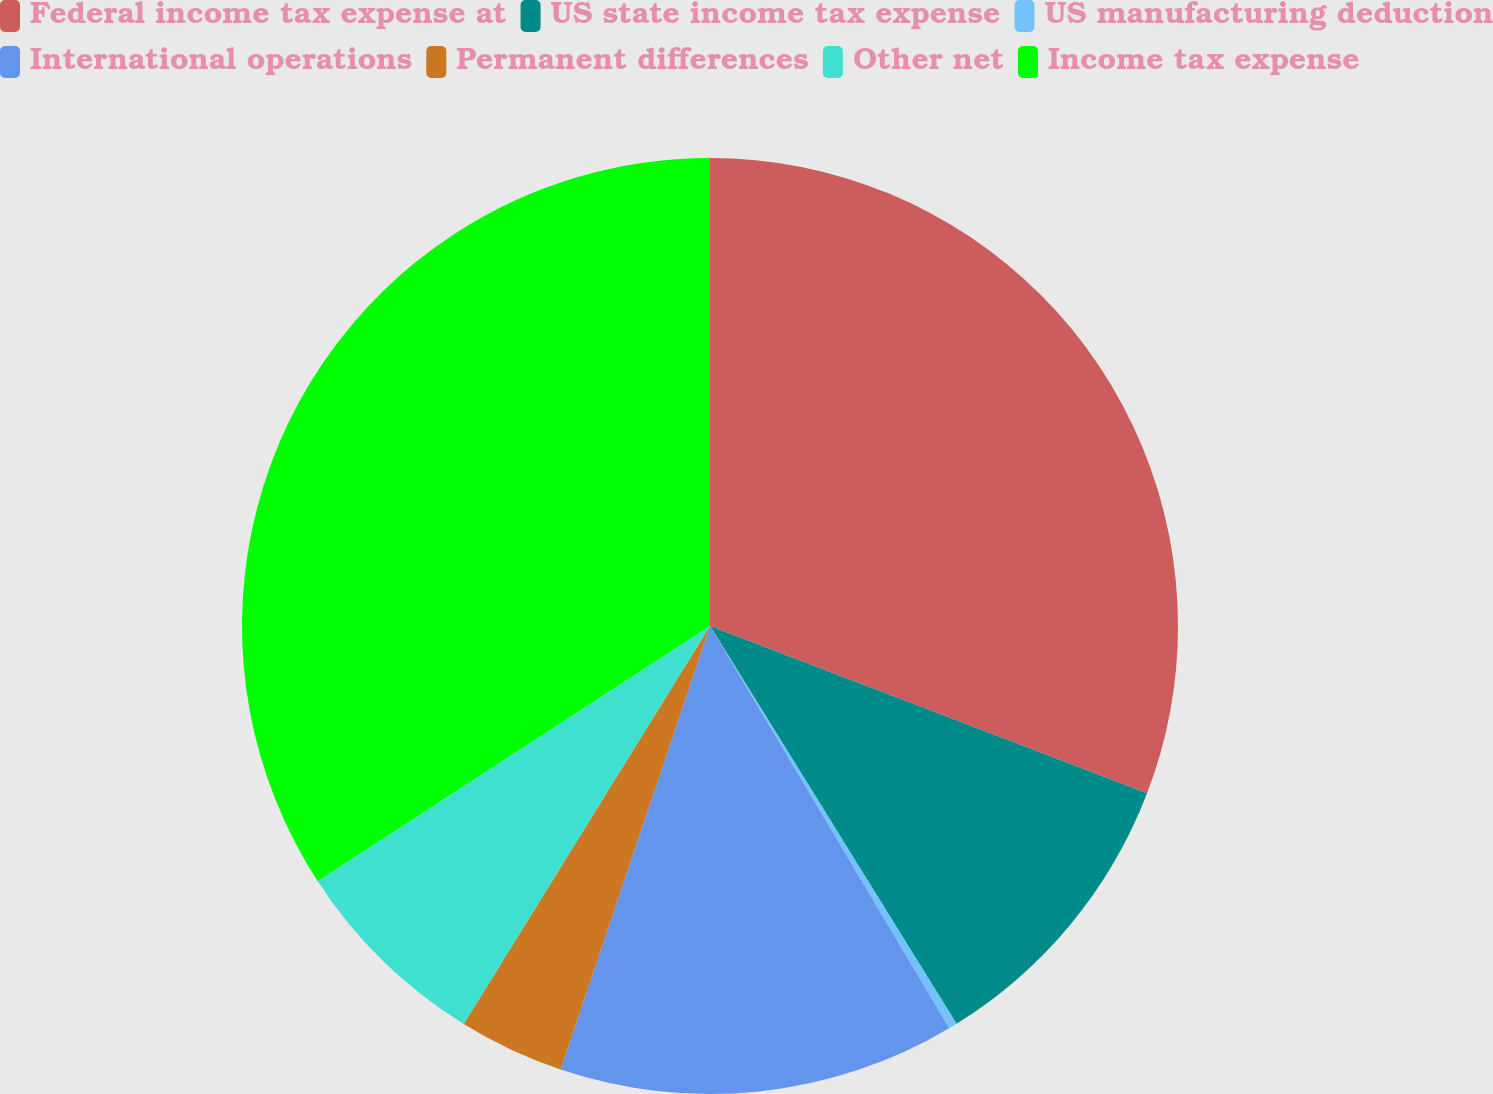Convert chart to OTSL. <chart><loc_0><loc_0><loc_500><loc_500><pie_chart><fcel>Federal income tax expense at<fcel>US state income tax expense<fcel>US manufacturing deduction<fcel>International operations<fcel>Permanent differences<fcel>Other net<fcel>Income tax expense<nl><fcel>30.82%<fcel>10.35%<fcel>0.29%<fcel>13.71%<fcel>3.65%<fcel>7.0%<fcel>34.18%<nl></chart> 